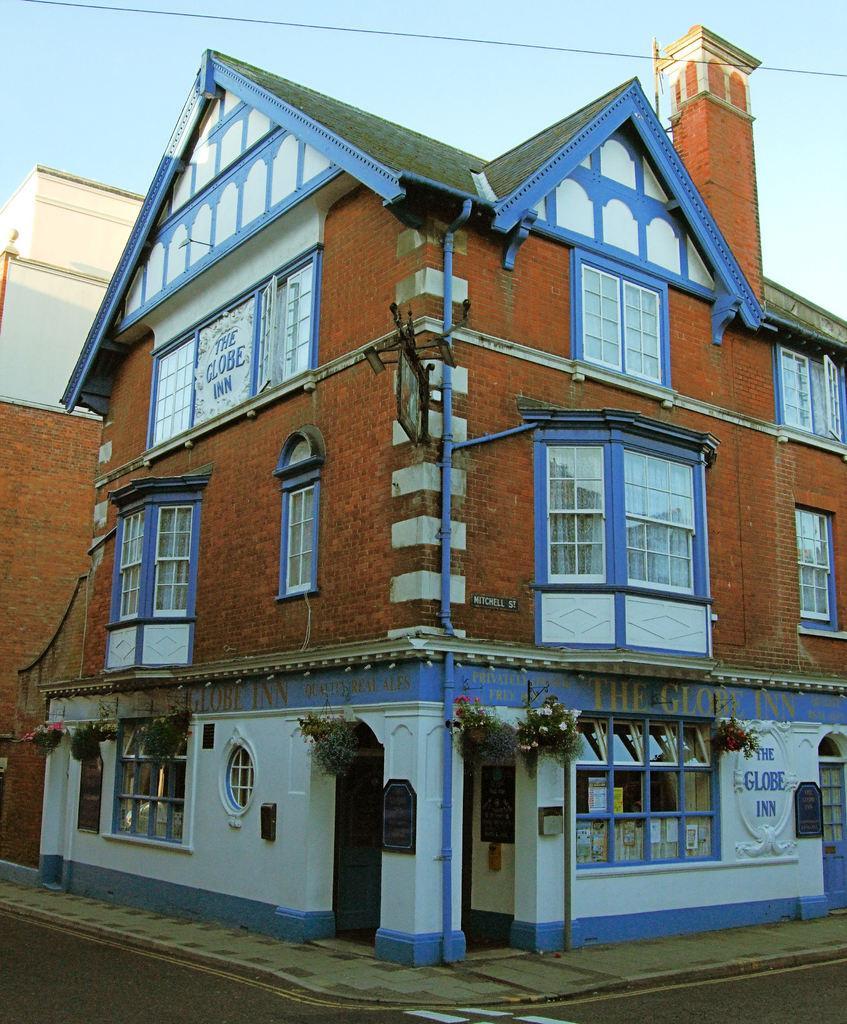Could you give a brief overview of what you see in this image? In the image we can see a building and the windows of the building, there are the pipes, plant, road, electric wire and a sky. 